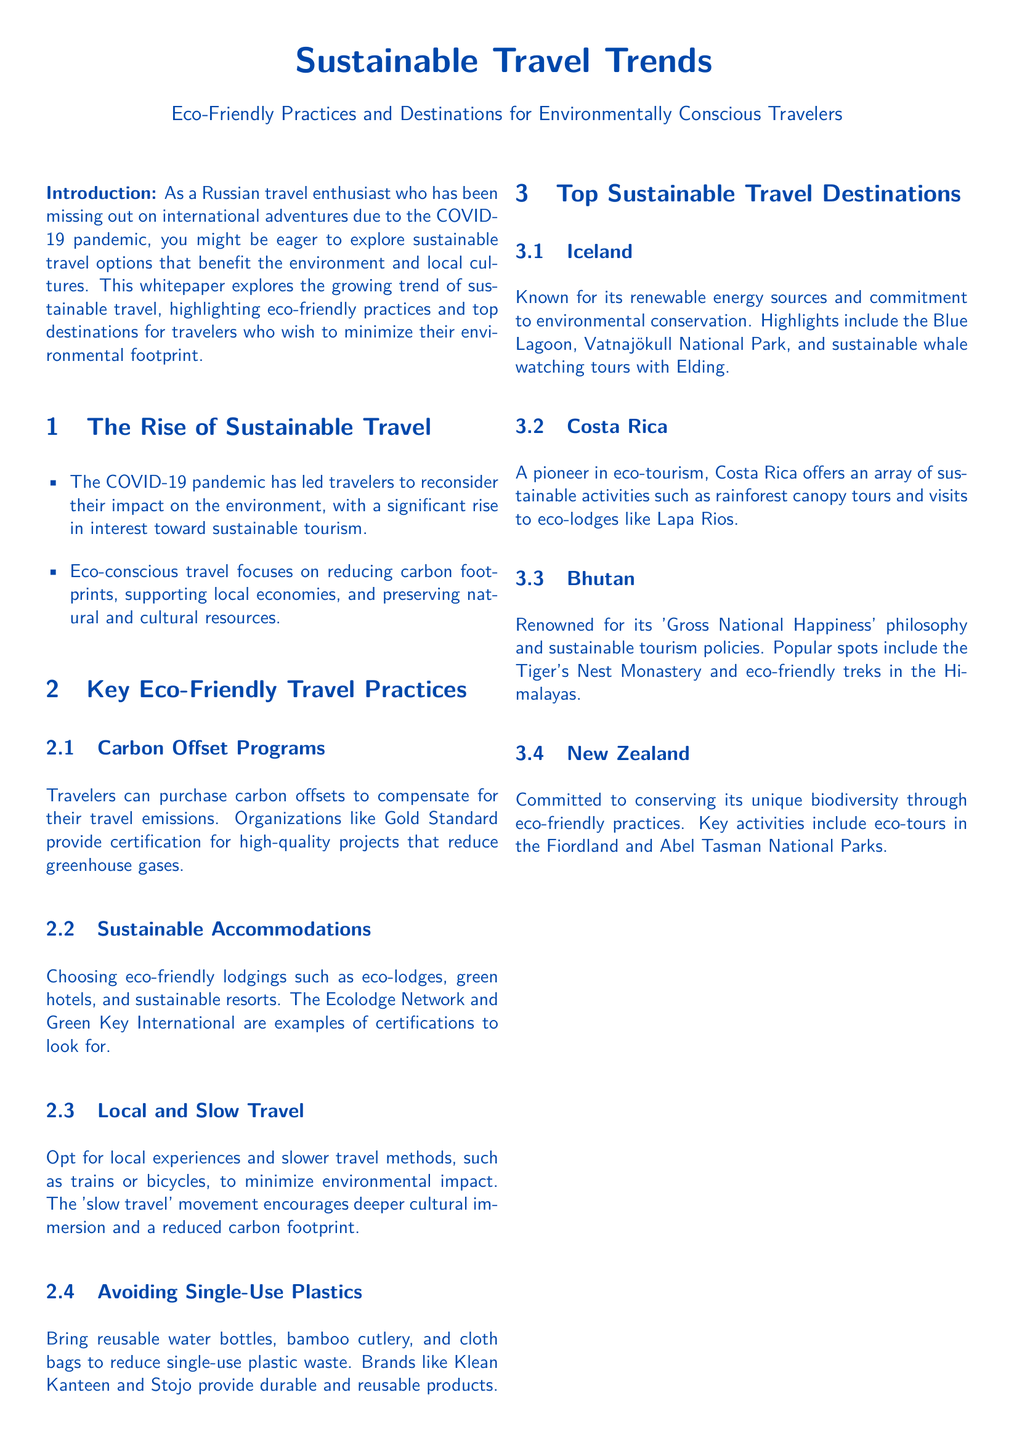What is the main topic of the document? The document discusses trends in travel, particularly those that are environmentally conscious and sustainable.
Answer: Sustainable Travel Trends What year did the COVID-19 pandemic affect travel perceptions? The document indicates that the pandemic has led travelers to reconsider their impact on the environment, suggesting this change occurred during the pandemic years.
Answer: 2020 Which certification organization is mentioned for carbon offset programs? Gold Standard is specified as an organization providing certification for carbon offset projects.
Answer: Gold Standard What type of travel does the document recommend for minimizing environmental impact? The document suggests opting for slower travel methods to reduce the carbon footprint.
Answer: Slow travel Name one eco-friendly accommodation organization mentioned. The document lists The Ecolodge Network as a source of certification for sustainable lodgings.
Answer: The Ecolodge Network Which country is highlighted for its 'Gross National Happiness' philosophy? Bhutan is noted for its unique philosophy and sustainable tourism policies.
Answer: Bhutan What is one of the top sustainable destinations mentioned? The document specifically mentions Iceland as a key eco-friendly travel destination.
Answer: Iceland What practice does the document suggest to avoid plastic waste? The document advises against using single-use plastics by suggesting alternatives like reusable items.
Answer: Avoiding Single-Use Plastics 